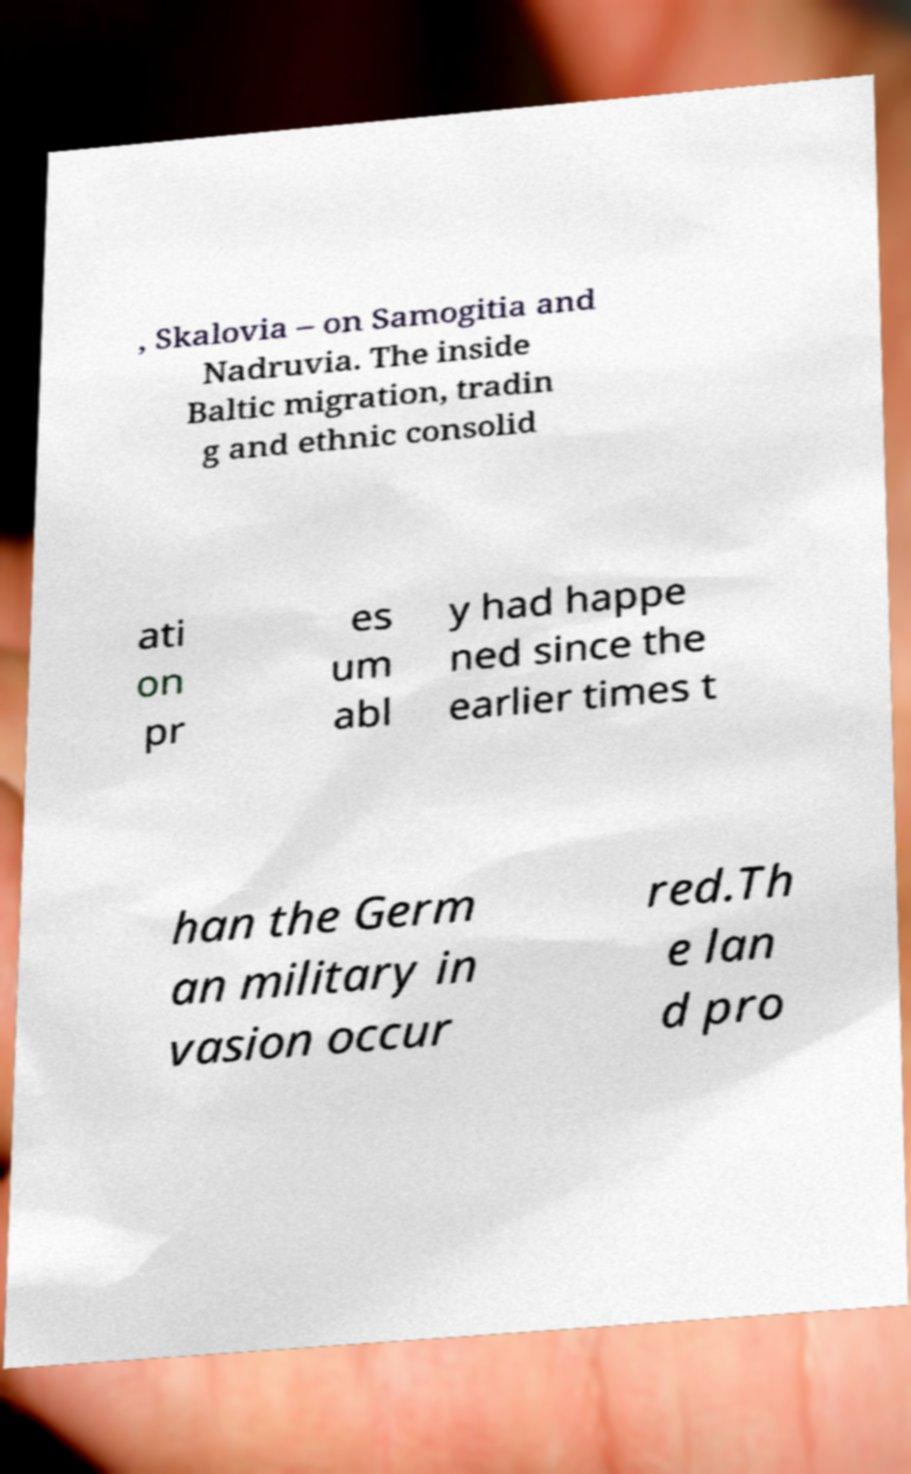Could you assist in decoding the text presented in this image and type it out clearly? , Skalovia – on Samogitia and Nadruvia. The inside Baltic migration, tradin g and ethnic consolid ati on pr es um abl y had happe ned since the earlier times t han the Germ an military in vasion occur red.Th e lan d pro 